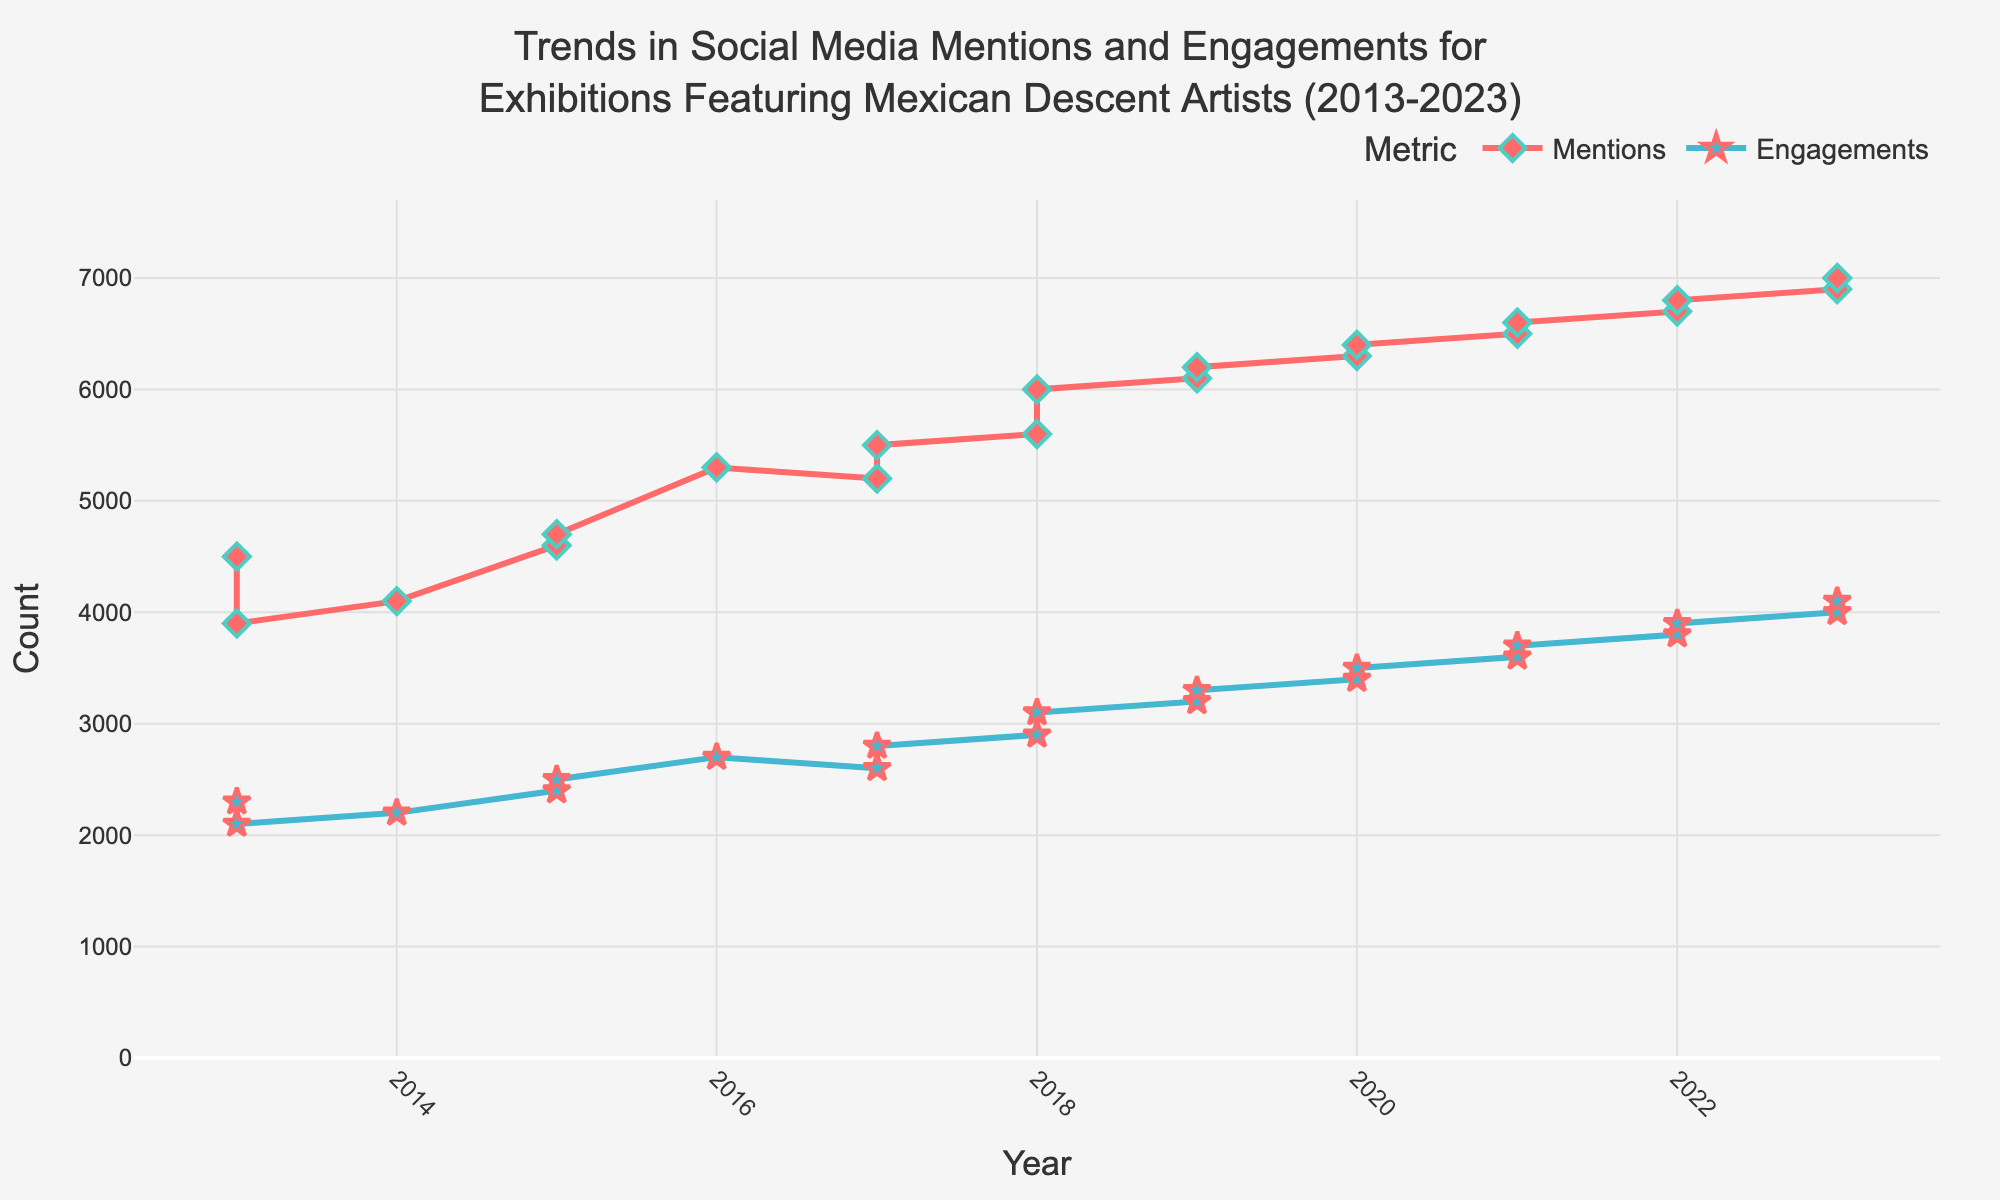what is the title of the figure? The title of the figure is usually located at the top and is the most prominent text. In this case, it should mention the trends in social media mentions and engagements.
Answer: Trends in Social Media Mentions and Engagements for Exhibitions Featuring Mexican Descent Artists (2013-2023) How many unique exhibitions are depicted for the year 2020? Look for data points specifically in the year 2020 and count the number of unique exhibitions mentioned.
Answer: 2 In which year did "Manuel Álvarez Bravo: Shadows and Light" reach its peak mentions and engagements? Identify the year corresponding to the exhibition "Manuel Álvarez Bravo: Shadows and Light" and report the year it achieved its highest mentions and engagements as per the plot.
Answer: 2023 What is the trend for engagements between 2013 and 2023? Observe the line graph for engagements from 2013 to 2023 and summarize the overall trend. This requires understanding the overall direction of the data over time.
Answer: Increasing trend Which exhibition had the highest social media mentions in 2018? Locate the data points for the year 2018 and find the exhibition associated with the highest mentions value.
Answer: Mario García Torres: Illusion Brought Me Here Compare the engagements for "Teresa Margolles: Ya Basta Hijos de Puta" in 2017 with "Pedro Reyes: Return to Sender" in 2020. Which one is higher? Look at the engagement values for the exhibitions "Teresa Margolles: Ya Basta Hijos de Puta" in 2017 and "Pedro Reyes: Return to Sender" in 2020 and compare them.
Answer: Pedro Reyes: Return to Sender in 2020 What is the average number of social media mentions for exhibitions in 2021? Find the mentions values for the exhibitions in the year 2021 and compute their average. The values are for "Bruce Nauman: Disappearing Acts" and "Karla Black: Places." Sum these values and divide by the number of exhibitions.
Answer: (6500 + 6600) / 2 = 6550 What can you infer about the relationship between mentions and engagements for exhibitions over the years? Look at the trends of both mentions and engagements over the years and describe if they seem to correlate, diverge, or show some pattern in relation to each other.
Answer: Strong correlation Between 2013 and 2015, what was the increase in the number of social media engagements? Compare the engagement value in 2013 and 2015 by subtracting the engagement value in 2013 from that of 2015 to get the increase over these years.
Answer: 2400 - 2300 = 100 Identify one year where the number of mentions was less than the previous year. Look at the mentions data over the years and find any year where the value decreased compared to the previous year.
Answer: 2017 (5200) < 2016 (5300) 